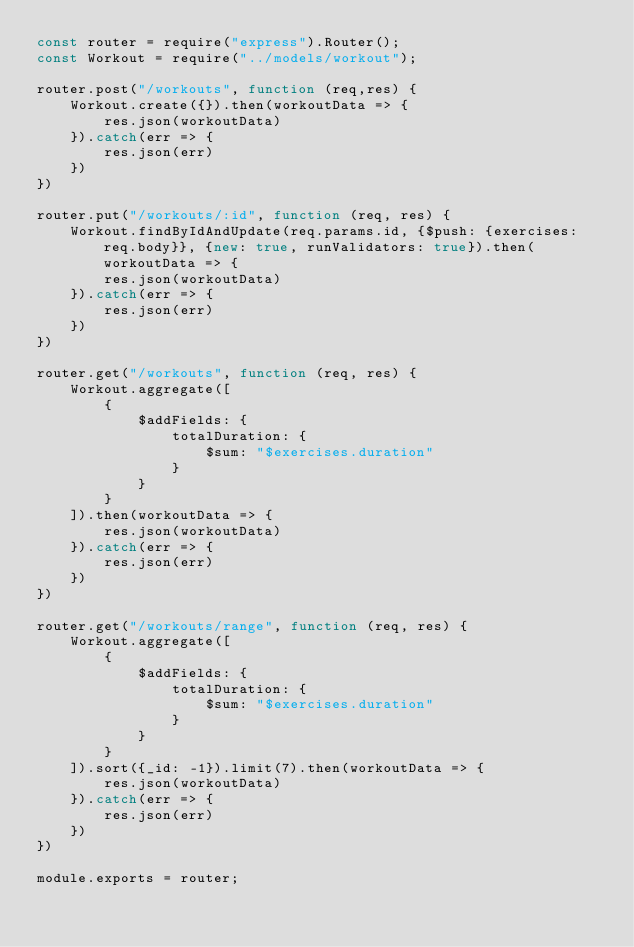Convert code to text. <code><loc_0><loc_0><loc_500><loc_500><_JavaScript_>const router = require("express").Router();
const Workout = require("../models/workout");

router.post("/workouts", function (req,res) {
    Workout.create({}).then(workoutData => {
        res.json(workoutData)
    }).catch(err => {
        res.json(err)
    })
})

router.put("/workouts/:id", function (req, res) {
    Workout.findByIdAndUpdate(req.params.id, {$push: {exercises: req.body}}, {new: true, runValidators: true}).then(workoutData => {
        res.json(workoutData)
    }).catch(err => {
        res.json(err)
    })
})

router.get("/workouts", function (req, res) {
    Workout.aggregate([
        {
            $addFields: {
                totalDuration: {
                    $sum: "$exercises.duration"
                }
            }
        }
    ]).then(workoutData => {
        res.json(workoutData)
    }).catch(err => {
        res.json(err)
    })
})

router.get("/workouts/range", function (req, res) {
    Workout.aggregate([
        {
            $addFields: {
                totalDuration: {
                    $sum: "$exercises.duration"
                }
            }
        }
    ]).sort({_id: -1}).limit(7).then(workoutData => {
        res.json(workoutData)
    }).catch(err => {
        res.json(err)
    })
})

module.exports = router;</code> 